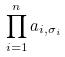<formula> <loc_0><loc_0><loc_500><loc_500>\prod _ { i = 1 } ^ { n } a _ { i , \sigma _ { i } }</formula> 